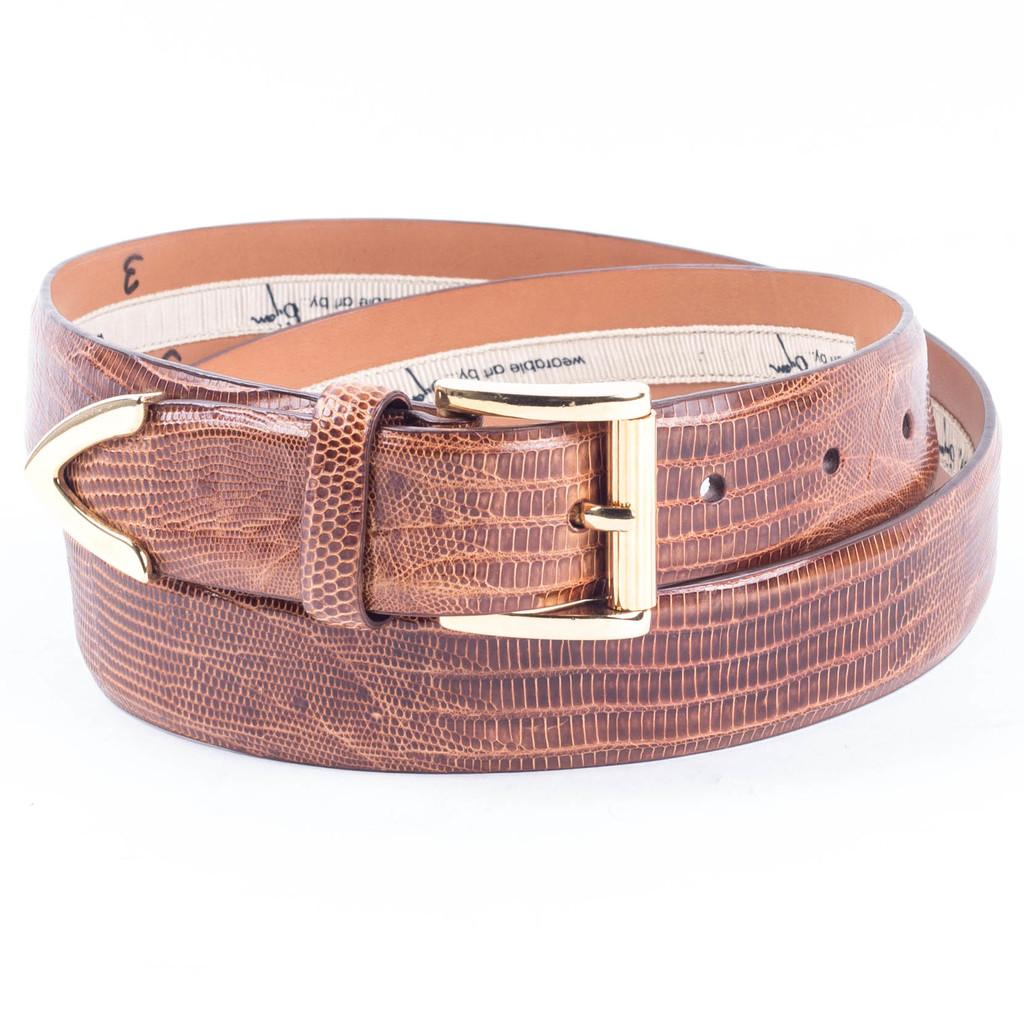What object can be seen in the image? There is a belt in the image. What is the color of the belt? The belt is brown in color. Where is the belt located in the image? The belt is placed on a table. What is the color of the background in the image? The background of the image is white. What type of oven is used to cook the interest in the image? There is no oven, interest, or cooking activity present in the image; it features a brown belt placed on a table with a white background. 